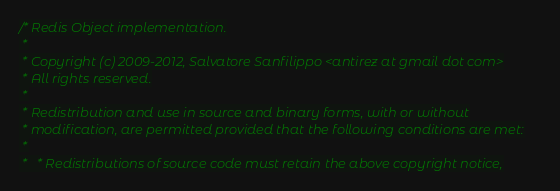<code> <loc_0><loc_0><loc_500><loc_500><_C_>/* Redis Object implementation.
 *
 * Copyright (c) 2009-2012, Salvatore Sanfilippo <antirez at gmail dot com>
 * All rights reserved.
 *
 * Redistribution and use in source and binary forms, with or without
 * modification, are permitted provided that the following conditions are met:
 *
 *   * Redistributions of source code must retain the above copyright notice,</code> 